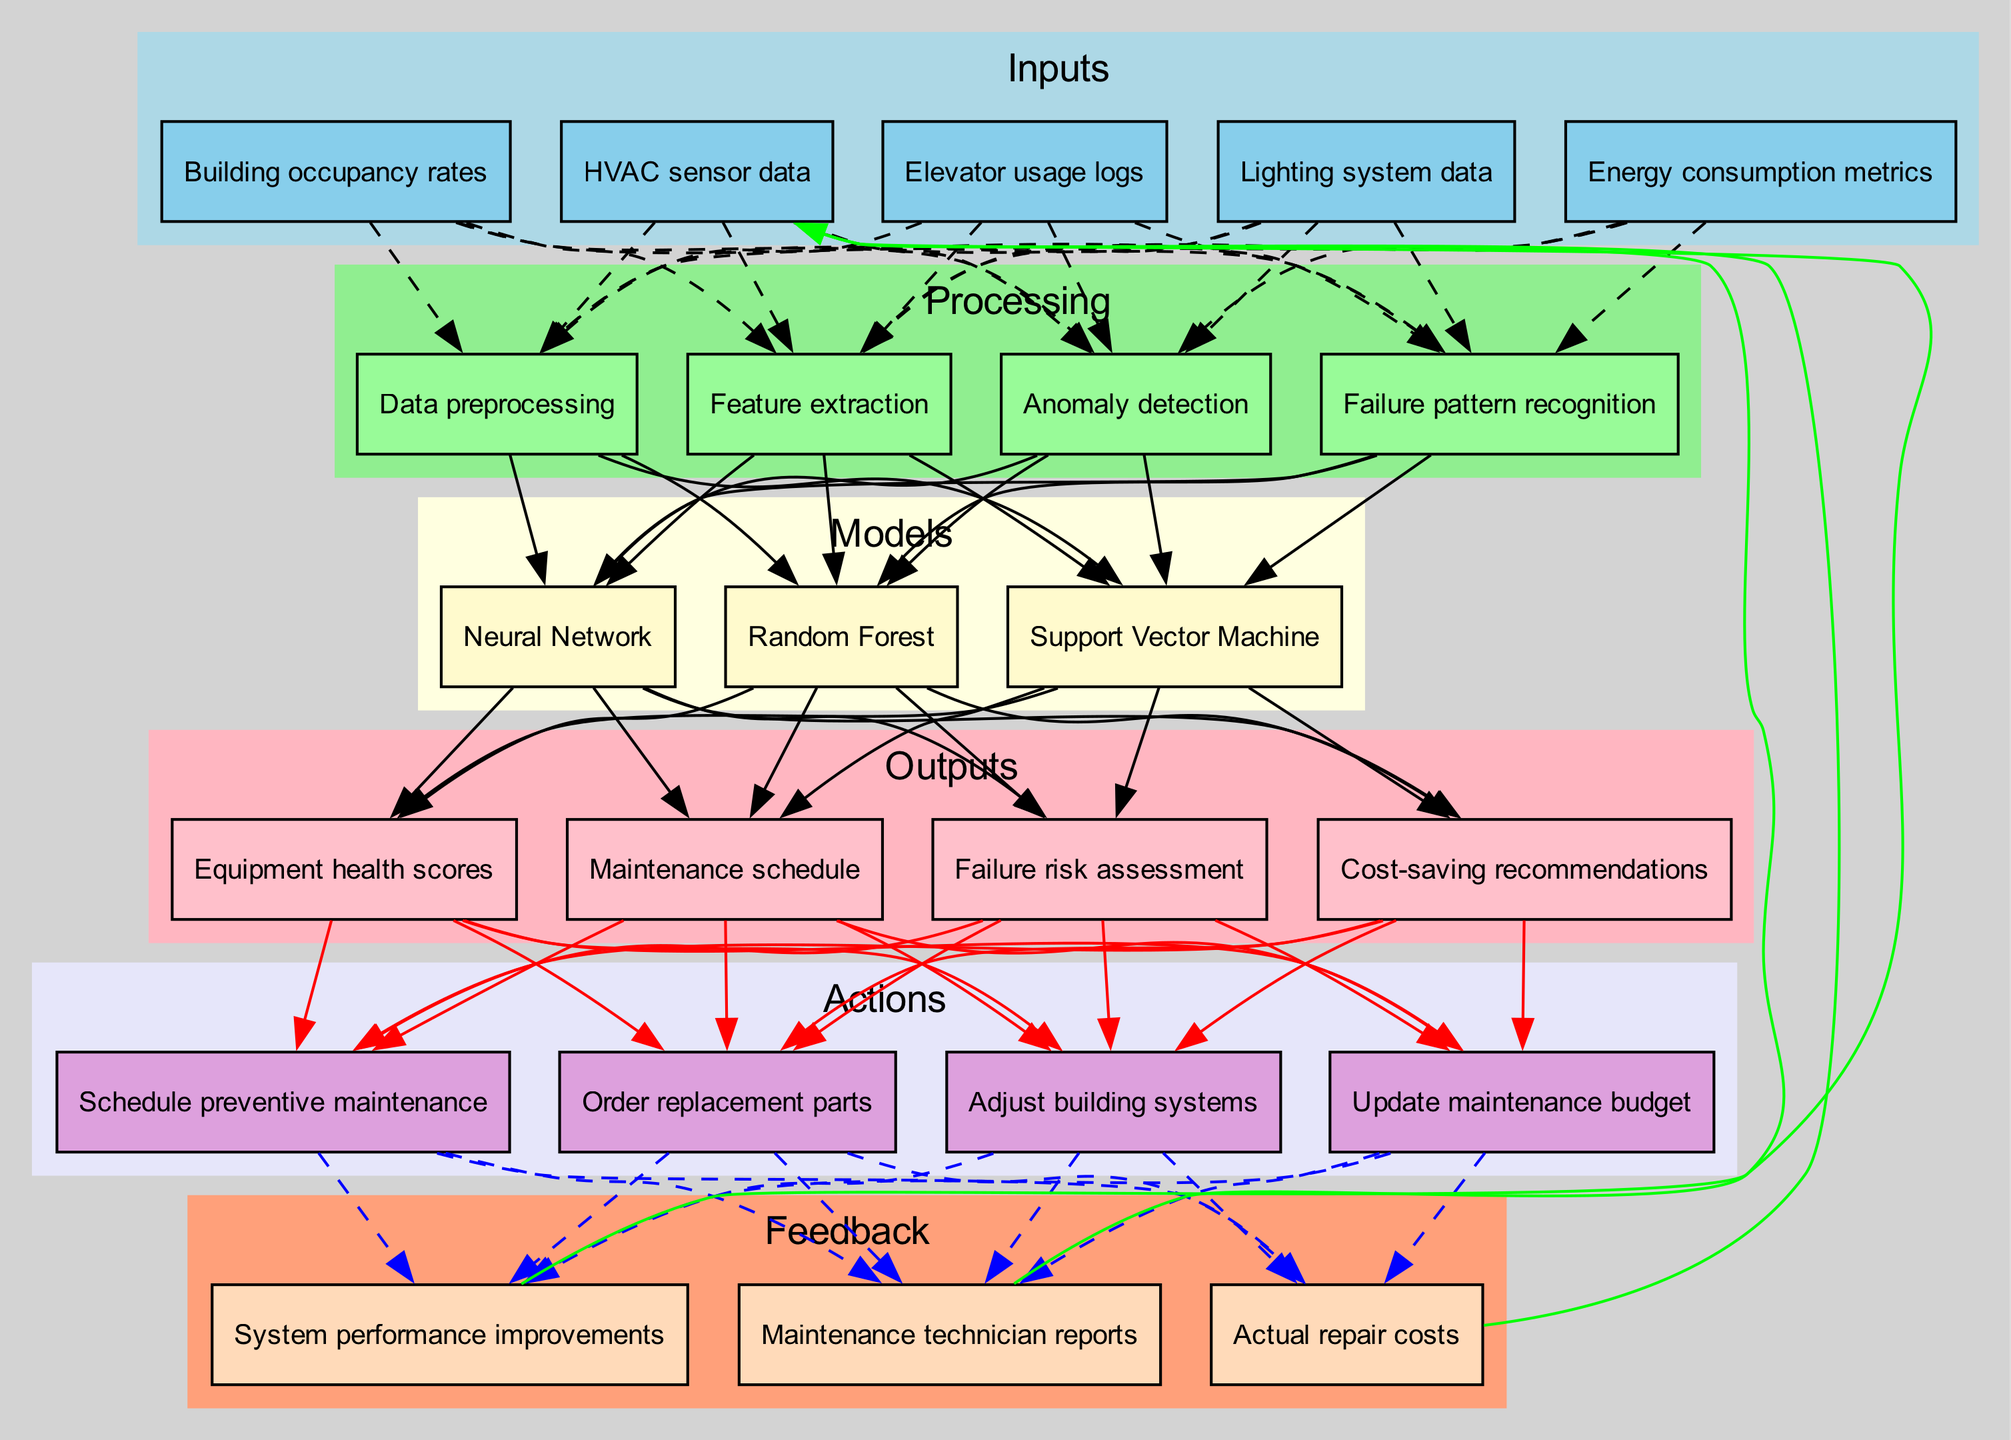What are the inputs of the predictive maintenance model? The inputs, as seen in the diagram, include various sensor and usage data essential for the model's functioning. They are HVAC sensor data, Elevator usage logs, Lighting system data, Energy consumption metrics, and Building occupancy rates.
Answer: HVAC sensor data, Elevator usage logs, Lighting system data, Energy consumption metrics, Building occupancy rates How many processing steps are shown in the diagram? By observing the 'Processing' section of the diagram, there are four processes listed: Data preprocessing, Feature extraction, Anomaly detection, and Failure pattern recognition. This counts to a total of four processing steps.
Answer: 4 Which model is used for predicting maintenance needs? In the 'Models' section, the diagram lists three different models, among which Random Forest is one of them, indicating that it’s utilized for predicting maintenance needs.
Answer: Random Forest What is the first output generated by the model? Looking at the 'Outputs' section, the first output listed is 'Equipment health scores', which indicates the initial result from the model's processing after feature extraction and pattern recognition.
Answer: Equipment health scores How do actions relate to outputs in the diagram? The diagram shows that actions such as Scheduling preventive maintenance, Ordering replacement parts, and Adjusting building systems are all connected to the outputs which means that these actions are taken based on the outputs generated from the predictive maintenance model.
Answer: They are connected; actions depend on outputs What feedback is used to improve future predictions? The diagram identifies three types of feedback: Maintenance technician reports, Actual repair costs, and System performance improvements, indicating that these forms of feedback contribute to refining future predictions in the model.
Answer: Maintenance technician reports, Actual repair costs, System performance improvements Which processing step directly follows feature extraction? Based on the processing order in the diagram, after feature extraction, the next step is Anomaly detection, showing the workflow in which the extracted features are analyzed for irregularities.
Answer: Anomaly detection How many feedback elements are there in the diagram? In the 'Feedback' section of the diagram, there are three distinct items listed: Maintenance technician reports, Actual repair costs, and System performance improvements, making a total of three feedback elements.
Answer: 3 